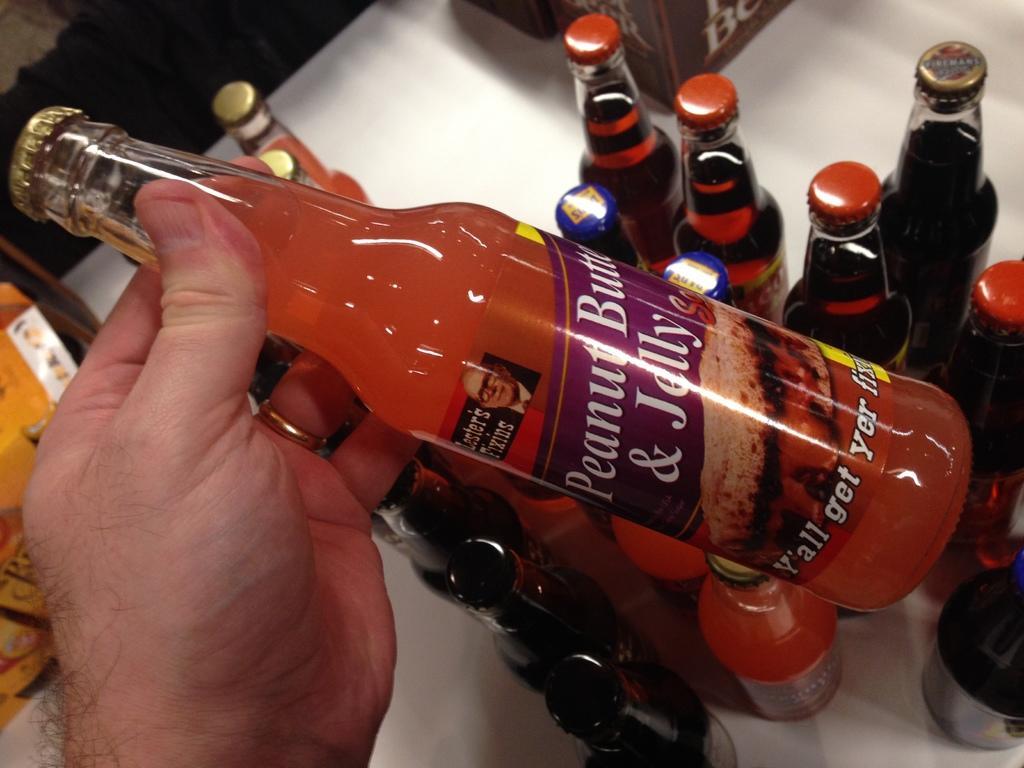Please provide a concise description of this image. On the left side of the picture there is hand holding a bottle. In the center of the picture there are many bottles on a table, on the top there is box. On the left there is another box. 